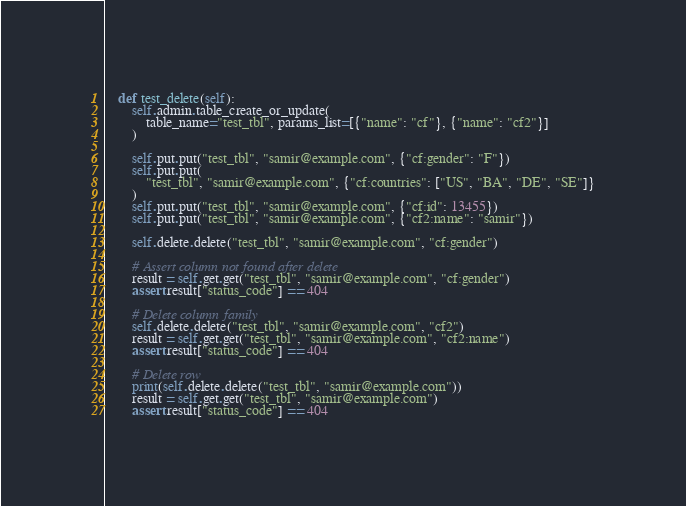Convert code to text. <code><loc_0><loc_0><loc_500><loc_500><_Python_>
    def test_delete(self):
        self.admin.table_create_or_update(
            table_name="test_tbl", params_list=[{"name": "cf"}, {"name": "cf2"}]
        )

        self.put.put("test_tbl", "samir@example.com", {"cf:gender": "F"})
        self.put.put(
            "test_tbl", "samir@example.com", {"cf:countries": ["US", "BA", "DE", "SE"]}
        )
        self.put.put("test_tbl", "samir@example.com", {"cf:id": 13455})
        self.put.put("test_tbl", "samir@example.com", {"cf2:name": "samir"})

        self.delete.delete("test_tbl", "samir@example.com", "cf:gender")

        # Assert column not found after delete
        result = self.get.get("test_tbl", "samir@example.com", "cf:gender")
        assert result["status_code"] == 404

        # Delete column family
        self.delete.delete("test_tbl", "samir@example.com", "cf2")
        result = self.get.get("test_tbl", "samir@example.com", "cf2:name")
        assert result["status_code"] == 404

        # Delete row
        print(self.delete.delete("test_tbl", "samir@example.com"))
        result = self.get.get("test_tbl", "samir@example.com")
        assert result["status_code"] == 404
</code> 